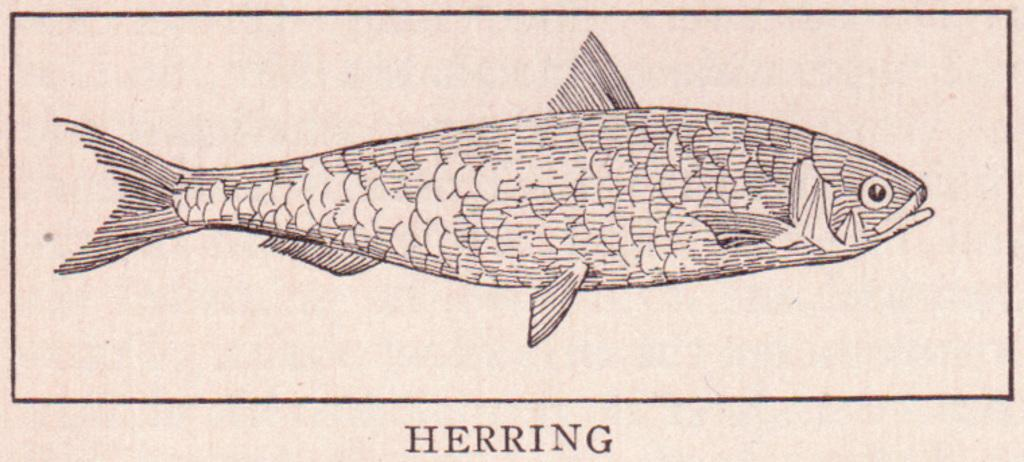What is the main subject of the sketch in the image? The main subject of the sketch in the image is a fish. What color is used for the sketch? The sketch is in black color. What type of pin is holding the fish sketch in the image? There is no pin present in the image; it is a sketch of a fish in black color. 